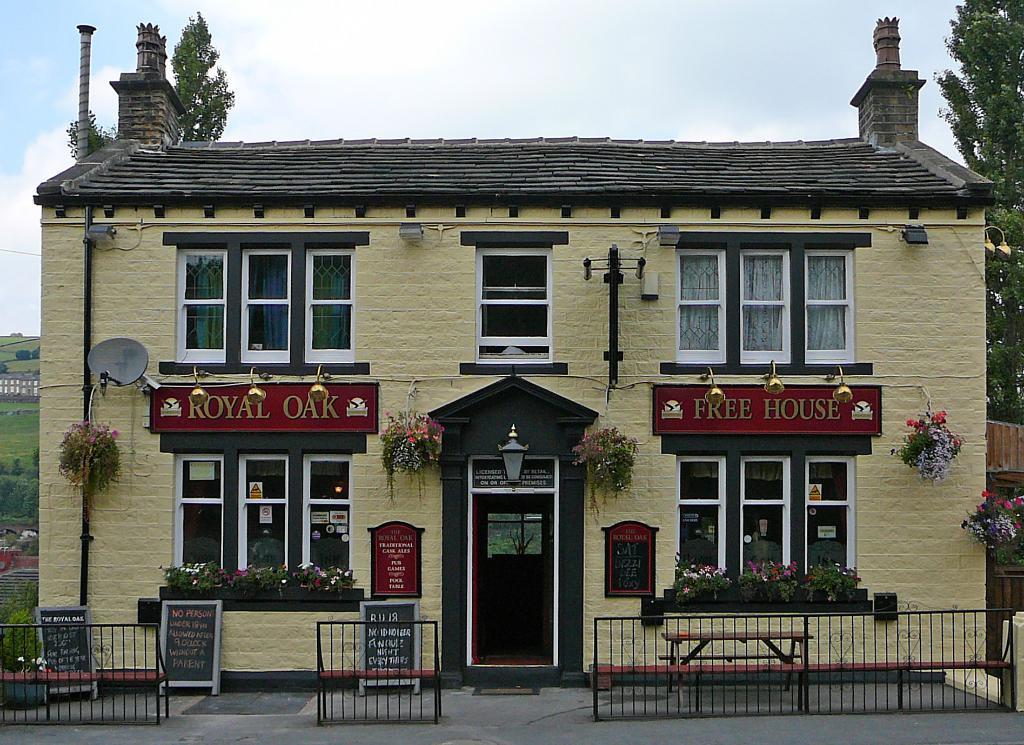Can you describe this image briefly? In this image I can see the house. There are many windows to the house. I can also see the decorative flowers and I can see two boards to the house. In-front of the house there is a railing and many black color boards to the left. In the background there are trees, ground and the sky. 